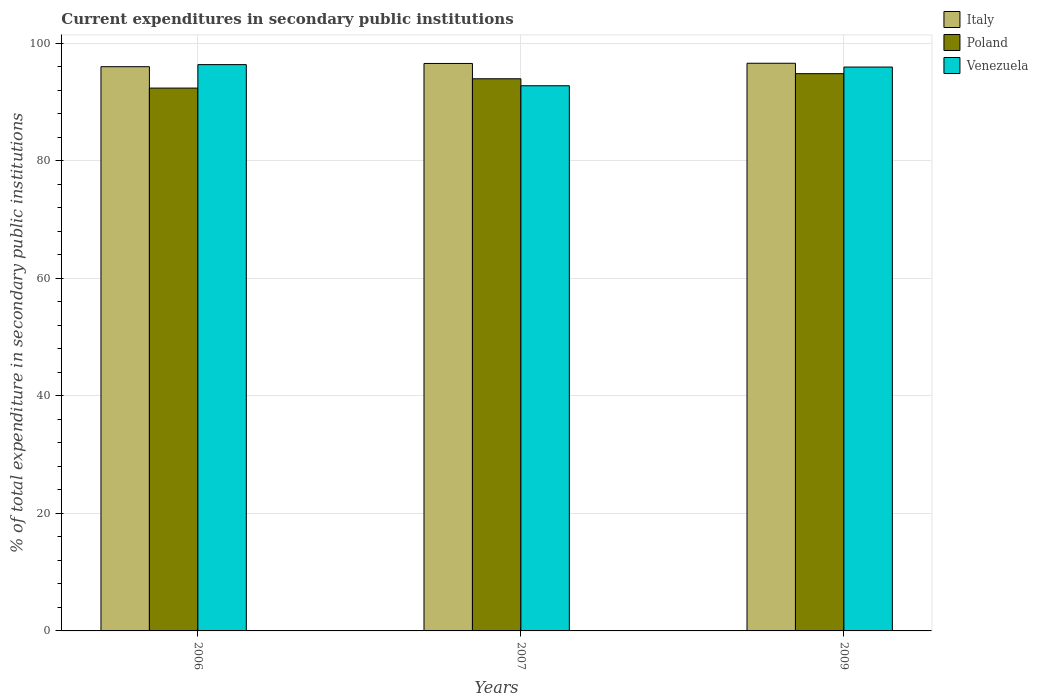Are the number of bars per tick equal to the number of legend labels?
Make the answer very short. Yes. Are the number of bars on each tick of the X-axis equal?
Provide a succinct answer. Yes. What is the label of the 2nd group of bars from the left?
Keep it short and to the point. 2007. What is the current expenditures in secondary public institutions in Poland in 2009?
Provide a short and direct response. 94.85. Across all years, what is the maximum current expenditures in secondary public institutions in Venezuela?
Provide a short and direct response. 96.39. Across all years, what is the minimum current expenditures in secondary public institutions in Poland?
Provide a short and direct response. 92.4. What is the total current expenditures in secondary public institutions in Italy in the graph?
Provide a succinct answer. 289.25. What is the difference between the current expenditures in secondary public institutions in Venezuela in 2006 and that in 2009?
Your answer should be very brief. 0.42. What is the difference between the current expenditures in secondary public institutions in Italy in 2009 and the current expenditures in secondary public institutions in Poland in 2006?
Your answer should be very brief. 4.23. What is the average current expenditures in secondary public institutions in Italy per year?
Your response must be concise. 96.42. In the year 2006, what is the difference between the current expenditures in secondary public institutions in Venezuela and current expenditures in secondary public institutions in Italy?
Your answer should be compact. 0.36. What is the ratio of the current expenditures in secondary public institutions in Poland in 2006 to that in 2009?
Provide a succinct answer. 0.97. Is the current expenditures in secondary public institutions in Venezuela in 2007 less than that in 2009?
Keep it short and to the point. Yes. What is the difference between the highest and the second highest current expenditures in secondary public institutions in Italy?
Provide a succinct answer. 0.03. What is the difference between the highest and the lowest current expenditures in secondary public institutions in Poland?
Keep it short and to the point. 2.45. In how many years, is the current expenditures in secondary public institutions in Italy greater than the average current expenditures in secondary public institutions in Italy taken over all years?
Ensure brevity in your answer.  2. What does the 3rd bar from the left in 2006 represents?
Provide a short and direct response. Venezuela. What does the 3rd bar from the right in 2007 represents?
Provide a succinct answer. Italy. Are the values on the major ticks of Y-axis written in scientific E-notation?
Keep it short and to the point. No. Where does the legend appear in the graph?
Give a very brief answer. Top right. How many legend labels are there?
Provide a short and direct response. 3. How are the legend labels stacked?
Provide a succinct answer. Vertical. What is the title of the graph?
Your response must be concise. Current expenditures in secondary public institutions. Does "Kyrgyz Republic" appear as one of the legend labels in the graph?
Keep it short and to the point. No. What is the label or title of the Y-axis?
Make the answer very short. % of total expenditure in secondary public institutions. What is the % of total expenditure in secondary public institutions of Italy in 2006?
Your answer should be very brief. 96.04. What is the % of total expenditure in secondary public institutions of Poland in 2006?
Make the answer very short. 92.4. What is the % of total expenditure in secondary public institutions of Venezuela in 2006?
Provide a succinct answer. 96.39. What is the % of total expenditure in secondary public institutions in Italy in 2007?
Provide a succinct answer. 96.59. What is the % of total expenditure in secondary public institutions in Poland in 2007?
Give a very brief answer. 93.98. What is the % of total expenditure in secondary public institutions of Venezuela in 2007?
Keep it short and to the point. 92.79. What is the % of total expenditure in secondary public institutions in Italy in 2009?
Give a very brief answer. 96.62. What is the % of total expenditure in secondary public institutions of Poland in 2009?
Provide a succinct answer. 94.85. What is the % of total expenditure in secondary public institutions of Venezuela in 2009?
Keep it short and to the point. 95.98. Across all years, what is the maximum % of total expenditure in secondary public institutions of Italy?
Provide a short and direct response. 96.62. Across all years, what is the maximum % of total expenditure in secondary public institutions of Poland?
Provide a succinct answer. 94.85. Across all years, what is the maximum % of total expenditure in secondary public institutions of Venezuela?
Your answer should be very brief. 96.39. Across all years, what is the minimum % of total expenditure in secondary public institutions in Italy?
Offer a very short reply. 96.04. Across all years, what is the minimum % of total expenditure in secondary public institutions in Poland?
Your answer should be very brief. 92.4. Across all years, what is the minimum % of total expenditure in secondary public institutions of Venezuela?
Offer a terse response. 92.79. What is the total % of total expenditure in secondary public institutions of Italy in the graph?
Your response must be concise. 289.25. What is the total % of total expenditure in secondary public institutions in Poland in the graph?
Make the answer very short. 281.23. What is the total % of total expenditure in secondary public institutions of Venezuela in the graph?
Ensure brevity in your answer.  285.16. What is the difference between the % of total expenditure in secondary public institutions in Italy in 2006 and that in 2007?
Your response must be concise. -0.55. What is the difference between the % of total expenditure in secondary public institutions of Poland in 2006 and that in 2007?
Offer a very short reply. -1.58. What is the difference between the % of total expenditure in secondary public institutions in Venezuela in 2006 and that in 2007?
Provide a short and direct response. 3.6. What is the difference between the % of total expenditure in secondary public institutions of Italy in 2006 and that in 2009?
Your answer should be very brief. -0.59. What is the difference between the % of total expenditure in secondary public institutions of Poland in 2006 and that in 2009?
Offer a terse response. -2.45. What is the difference between the % of total expenditure in secondary public institutions in Venezuela in 2006 and that in 2009?
Give a very brief answer. 0.42. What is the difference between the % of total expenditure in secondary public institutions of Italy in 2007 and that in 2009?
Your answer should be very brief. -0.03. What is the difference between the % of total expenditure in secondary public institutions in Poland in 2007 and that in 2009?
Ensure brevity in your answer.  -0.87. What is the difference between the % of total expenditure in secondary public institutions in Venezuela in 2007 and that in 2009?
Ensure brevity in your answer.  -3.18. What is the difference between the % of total expenditure in secondary public institutions in Italy in 2006 and the % of total expenditure in secondary public institutions in Poland in 2007?
Your answer should be compact. 2.06. What is the difference between the % of total expenditure in secondary public institutions of Italy in 2006 and the % of total expenditure in secondary public institutions of Venezuela in 2007?
Provide a short and direct response. 3.25. What is the difference between the % of total expenditure in secondary public institutions of Poland in 2006 and the % of total expenditure in secondary public institutions of Venezuela in 2007?
Your answer should be very brief. -0.39. What is the difference between the % of total expenditure in secondary public institutions of Italy in 2006 and the % of total expenditure in secondary public institutions of Poland in 2009?
Provide a succinct answer. 1.19. What is the difference between the % of total expenditure in secondary public institutions in Italy in 2006 and the % of total expenditure in secondary public institutions in Venezuela in 2009?
Offer a terse response. 0.06. What is the difference between the % of total expenditure in secondary public institutions of Poland in 2006 and the % of total expenditure in secondary public institutions of Venezuela in 2009?
Your response must be concise. -3.58. What is the difference between the % of total expenditure in secondary public institutions of Italy in 2007 and the % of total expenditure in secondary public institutions of Poland in 2009?
Offer a terse response. 1.74. What is the difference between the % of total expenditure in secondary public institutions in Italy in 2007 and the % of total expenditure in secondary public institutions in Venezuela in 2009?
Provide a succinct answer. 0.61. What is the difference between the % of total expenditure in secondary public institutions in Poland in 2007 and the % of total expenditure in secondary public institutions in Venezuela in 2009?
Offer a very short reply. -1.99. What is the average % of total expenditure in secondary public institutions of Italy per year?
Offer a terse response. 96.42. What is the average % of total expenditure in secondary public institutions in Poland per year?
Offer a very short reply. 93.74. What is the average % of total expenditure in secondary public institutions in Venezuela per year?
Ensure brevity in your answer.  95.05. In the year 2006, what is the difference between the % of total expenditure in secondary public institutions of Italy and % of total expenditure in secondary public institutions of Poland?
Keep it short and to the point. 3.64. In the year 2006, what is the difference between the % of total expenditure in secondary public institutions of Italy and % of total expenditure in secondary public institutions of Venezuela?
Your answer should be very brief. -0.36. In the year 2006, what is the difference between the % of total expenditure in secondary public institutions in Poland and % of total expenditure in secondary public institutions in Venezuela?
Keep it short and to the point. -4. In the year 2007, what is the difference between the % of total expenditure in secondary public institutions of Italy and % of total expenditure in secondary public institutions of Poland?
Your answer should be very brief. 2.61. In the year 2007, what is the difference between the % of total expenditure in secondary public institutions of Italy and % of total expenditure in secondary public institutions of Venezuela?
Offer a terse response. 3.8. In the year 2007, what is the difference between the % of total expenditure in secondary public institutions of Poland and % of total expenditure in secondary public institutions of Venezuela?
Keep it short and to the point. 1.19. In the year 2009, what is the difference between the % of total expenditure in secondary public institutions of Italy and % of total expenditure in secondary public institutions of Poland?
Offer a very short reply. 1.77. In the year 2009, what is the difference between the % of total expenditure in secondary public institutions of Italy and % of total expenditure in secondary public institutions of Venezuela?
Ensure brevity in your answer.  0.65. In the year 2009, what is the difference between the % of total expenditure in secondary public institutions of Poland and % of total expenditure in secondary public institutions of Venezuela?
Your answer should be very brief. -1.12. What is the ratio of the % of total expenditure in secondary public institutions in Poland in 2006 to that in 2007?
Provide a short and direct response. 0.98. What is the ratio of the % of total expenditure in secondary public institutions in Venezuela in 2006 to that in 2007?
Offer a very short reply. 1.04. What is the ratio of the % of total expenditure in secondary public institutions of Poland in 2006 to that in 2009?
Ensure brevity in your answer.  0.97. What is the ratio of the % of total expenditure in secondary public institutions of Venezuela in 2006 to that in 2009?
Give a very brief answer. 1. What is the ratio of the % of total expenditure in secondary public institutions of Poland in 2007 to that in 2009?
Offer a terse response. 0.99. What is the ratio of the % of total expenditure in secondary public institutions of Venezuela in 2007 to that in 2009?
Offer a very short reply. 0.97. What is the difference between the highest and the second highest % of total expenditure in secondary public institutions in Italy?
Provide a succinct answer. 0.03. What is the difference between the highest and the second highest % of total expenditure in secondary public institutions of Poland?
Make the answer very short. 0.87. What is the difference between the highest and the second highest % of total expenditure in secondary public institutions of Venezuela?
Provide a short and direct response. 0.42. What is the difference between the highest and the lowest % of total expenditure in secondary public institutions in Italy?
Make the answer very short. 0.59. What is the difference between the highest and the lowest % of total expenditure in secondary public institutions of Poland?
Your answer should be compact. 2.45. What is the difference between the highest and the lowest % of total expenditure in secondary public institutions of Venezuela?
Provide a short and direct response. 3.6. 